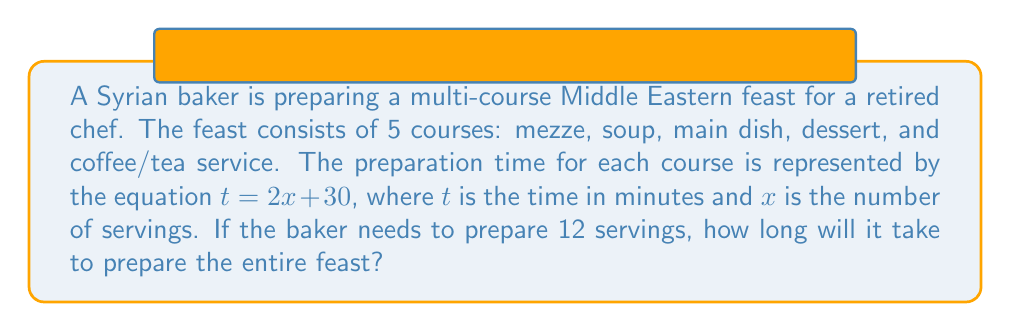Could you help me with this problem? 1. First, we need to calculate the time for one course:
   $t = 2x + 30$, where $x = 12$ servings
   $t = 2(12) + 30$
   $t = 24 + 30 = 54$ minutes per course

2. Since there are 5 courses, we multiply the time for one course by 5:
   Total time = $54 \times 5 = 270$ minutes

3. To convert minutes to hours and minutes:
   $270 \div 60 = 4$ hours with a remainder of $30$ minutes

Therefore, it will take 4 hours and 30 minutes to prepare the entire feast.
Answer: 4 hours and 30 minutes 